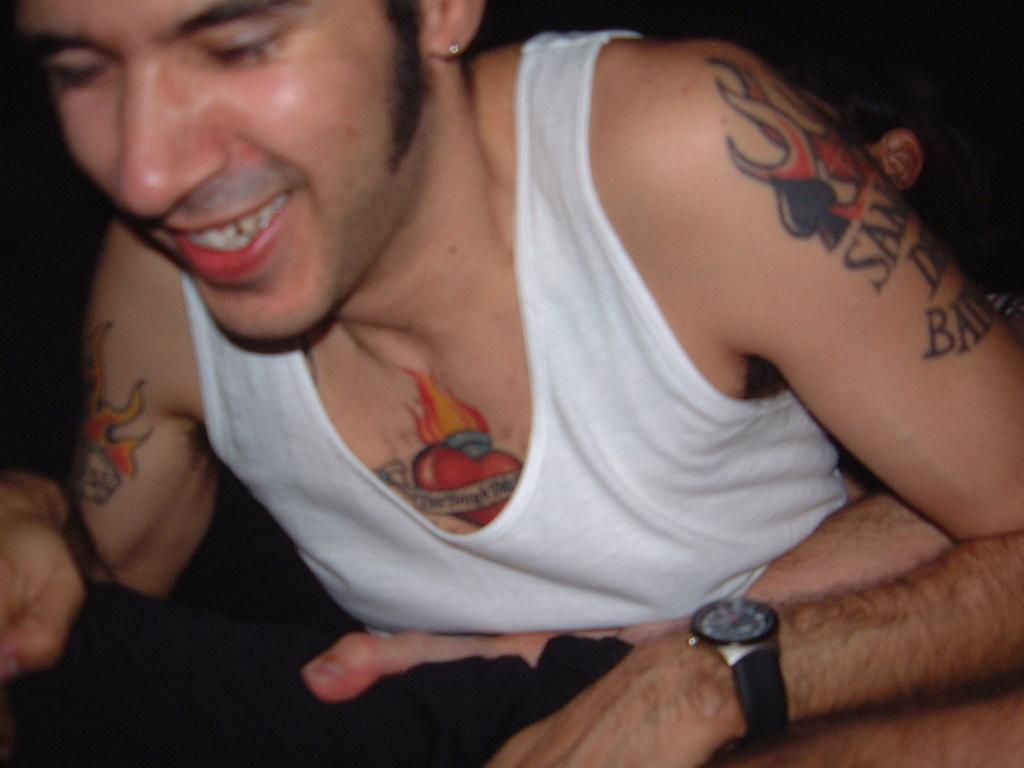Can you describe this image briefly? In the image there is a man with vest. And on his body there are many tattoos and he is smiling. 